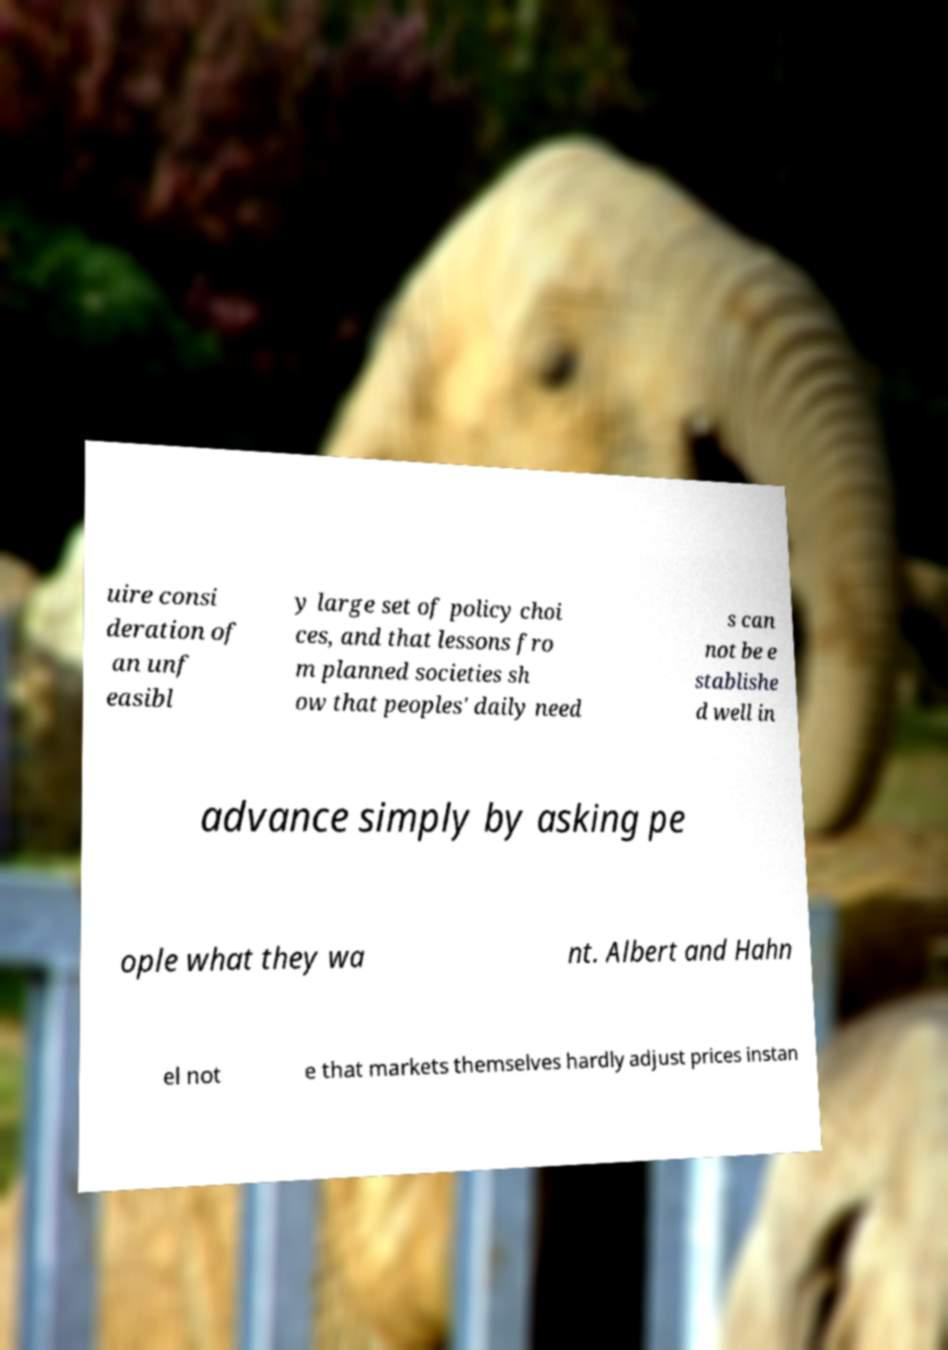Could you extract and type out the text from this image? uire consi deration of an unf easibl y large set of policy choi ces, and that lessons fro m planned societies sh ow that peoples' daily need s can not be e stablishe d well in advance simply by asking pe ople what they wa nt. Albert and Hahn el not e that markets themselves hardly adjust prices instan 